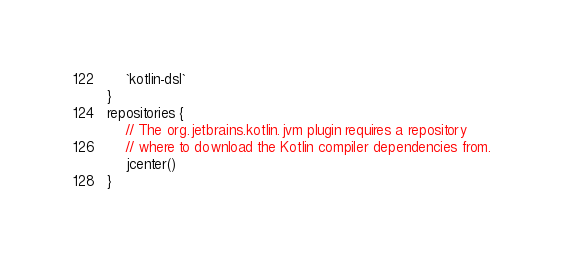<code> <loc_0><loc_0><loc_500><loc_500><_Kotlin_>    `kotlin-dsl`
}
repositories {
    // The org.jetbrains.kotlin.jvm plugin requires a repository
    // where to download the Kotlin compiler dependencies from.
    jcenter()
}
</code> 